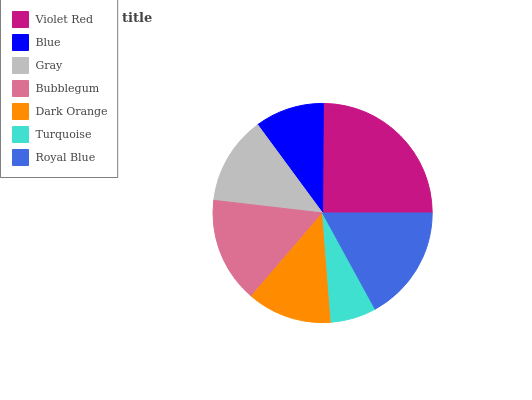Is Turquoise the minimum?
Answer yes or no. Yes. Is Violet Red the maximum?
Answer yes or no. Yes. Is Blue the minimum?
Answer yes or no. No. Is Blue the maximum?
Answer yes or no. No. Is Violet Red greater than Blue?
Answer yes or no. Yes. Is Blue less than Violet Red?
Answer yes or no. Yes. Is Blue greater than Violet Red?
Answer yes or no. No. Is Violet Red less than Blue?
Answer yes or no. No. Is Gray the high median?
Answer yes or no. Yes. Is Gray the low median?
Answer yes or no. Yes. Is Turquoise the high median?
Answer yes or no. No. Is Royal Blue the low median?
Answer yes or no. No. 